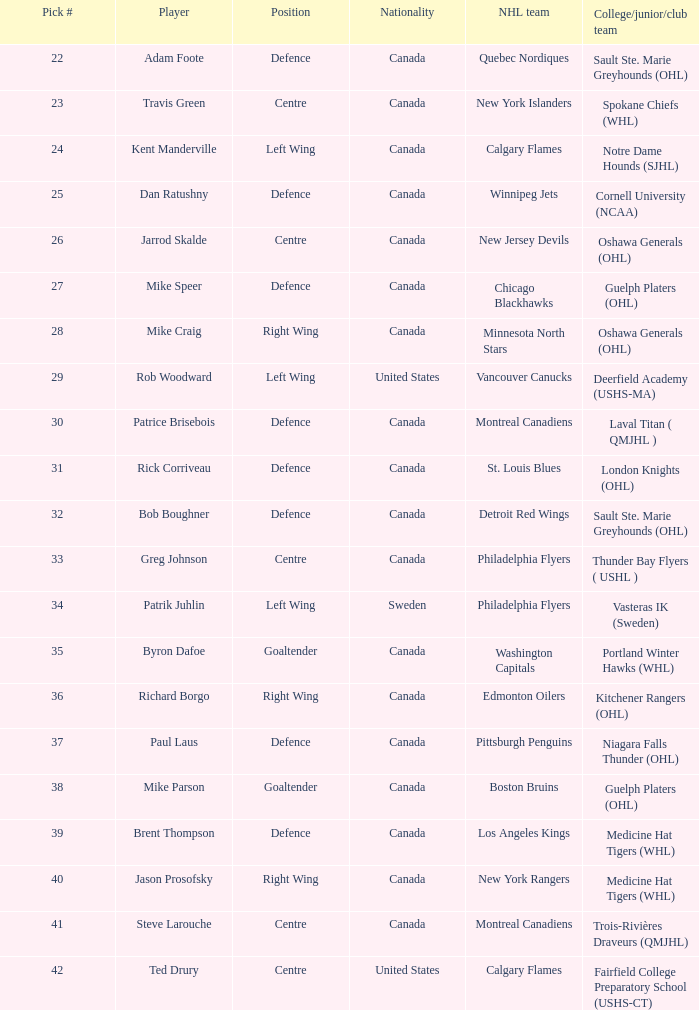What is the number of draft picks for player byron dafoe? 1.0. 